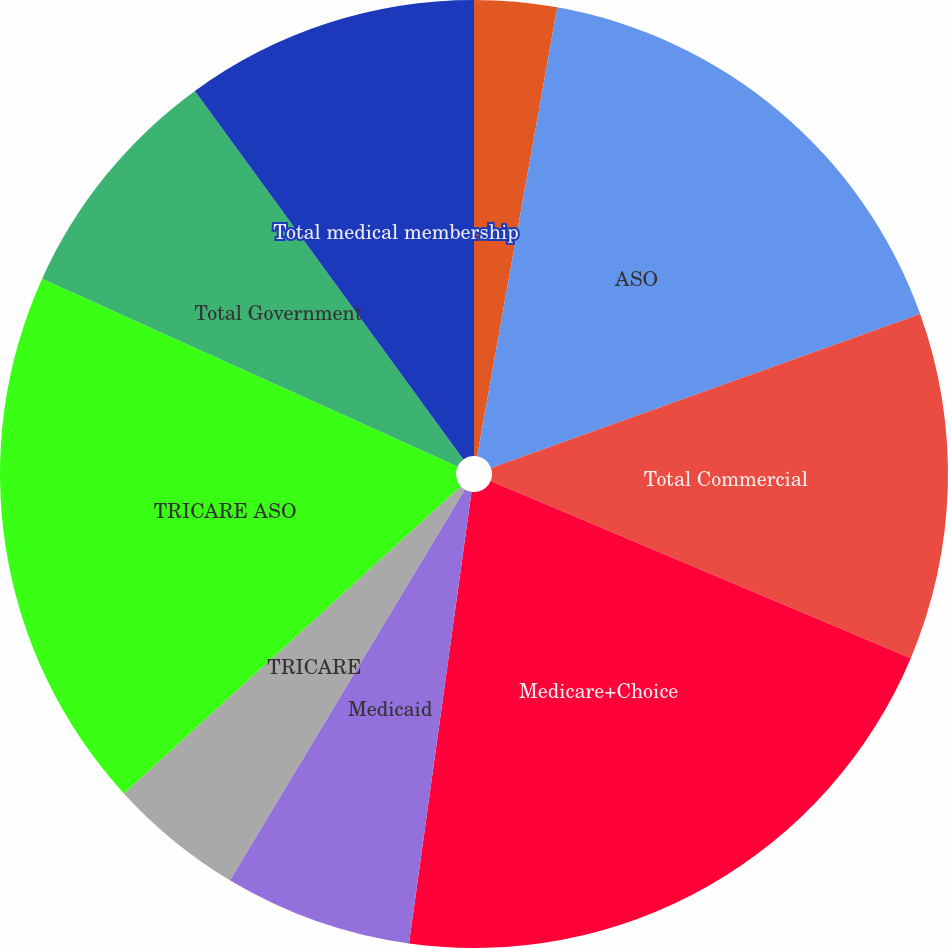Convert chart to OTSL. <chart><loc_0><loc_0><loc_500><loc_500><pie_chart><fcel>Fully insured<fcel>ASO<fcel>Total Commercial<fcel>Medicare+Choice<fcel>Medicaid<fcel>TRICARE<fcel>TRICARE ASO<fcel>Total Government<fcel>Total medical membership<nl><fcel>2.81%<fcel>16.71%<fcel>11.83%<fcel>20.84%<fcel>6.42%<fcel>4.62%<fcel>18.53%<fcel>8.22%<fcel>10.02%<nl></chart> 